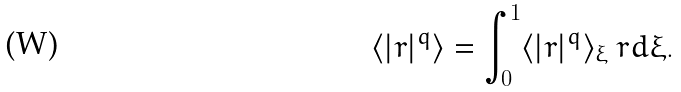<formula> <loc_0><loc_0><loc_500><loc_500>\langle | r | ^ { q } \rangle = \int _ { 0 } ^ { 1 } \langle | r | ^ { q } \rangle _ { \xi } \ r d \xi .</formula> 